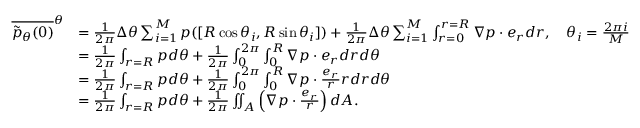Convert formula to latex. <formula><loc_0><loc_0><loc_500><loc_500>\begin{array} { r l } { \overline { { \tilde { p } _ { \theta } ( 0 ) } } ^ { \theta } } & { = \frac { 1 } { 2 \pi } \Delta \theta \sum _ { i = 1 } ^ { M } p ( [ R \cos \theta _ { i } , R \sin \theta _ { i } ] ) + \frac { 1 } { 2 \pi } \Delta \theta \sum _ { i = 1 } ^ { M } \int _ { r = 0 } ^ { r = R } \nabla p \cdot e _ { r } d r , \quad \theta _ { i } = \frac { 2 \pi i } { M } } \\ & { = \frac { 1 } { 2 \pi } \int _ { r = R } p d \theta + \frac { 1 } { 2 \pi } \int _ { 0 } ^ { 2 \pi } \int _ { 0 } ^ { R } \nabla p \cdot e _ { r } d r d \theta } \\ & { = \frac { 1 } { 2 \pi } \int _ { r = R } p d \theta + \frac { 1 } { 2 \pi } \int _ { 0 } ^ { 2 \pi } \int _ { 0 } ^ { R } \nabla p \cdot \frac { e _ { r } } { r } r d r d \theta } \\ & { = \frac { 1 } { 2 \pi } \int _ { r = R } p d \theta + \frac { 1 } { 2 \pi } \iint _ { A } \left ( \nabla p \cdot \frac { e _ { r } } { r } \right ) d A . } \end{array}</formula> 